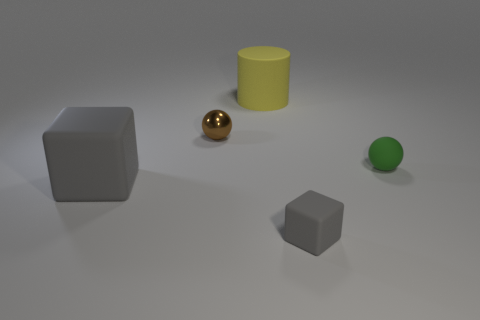Is there a green matte thing to the left of the thing that is behind the small thing behind the green object?
Your response must be concise. No. The green thing that is the same material as the large yellow thing is what size?
Your response must be concise. Small. Are there any rubber cylinders in front of the yellow object?
Your answer should be very brief. No. Are there any gray things to the left of the big thing behind the tiny matte sphere?
Ensure brevity in your answer.  Yes. Is the size of the ball on the right side of the tiny brown metal object the same as the rubber block that is on the left side of the tiny gray thing?
Your response must be concise. No. How many large objects are either rubber objects or red objects?
Offer a very short reply. 2. The small thing in front of the gray cube to the left of the yellow matte cylinder is made of what material?
Your answer should be very brief. Rubber. What is the shape of the tiny matte object that is the same color as the large block?
Offer a very short reply. Cube. Are there any yellow blocks that have the same material as the tiny green object?
Your response must be concise. No. Is the big cube made of the same material as the ball that is in front of the brown metal sphere?
Offer a terse response. Yes. 